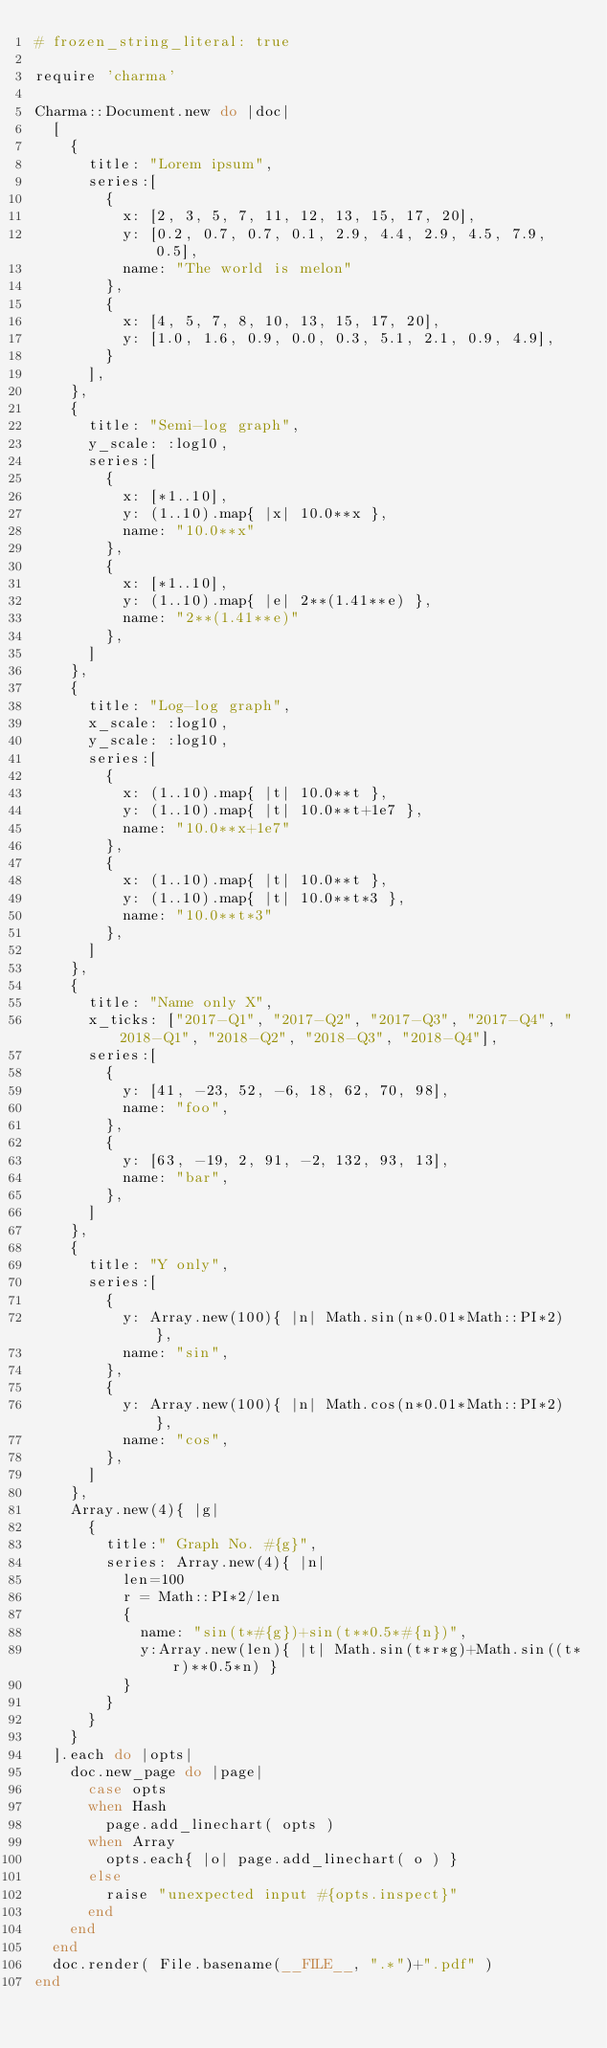<code> <loc_0><loc_0><loc_500><loc_500><_Ruby_># frozen_string_literal: true

require 'charma'

Charma::Document.new do |doc|
  [
    {
      title: "Lorem ipsum",
      series:[
        {
          x: [2, 3, 5, 7, 11, 12, 13, 15, 17, 20],
          y: [0.2, 0.7, 0.7, 0.1, 2.9, 4.4, 2.9, 4.5, 7.9, 0.5],
          name: "The world is melon"
        },
        {
          x: [4, 5, 7, 8, 10, 13, 15, 17, 20],
          y: [1.0, 1.6, 0.9, 0.0, 0.3, 5.1, 2.1, 0.9, 4.9],
        }
      ],
    },
    {
      title: "Semi-log graph",
      y_scale: :log10,
      series:[
        {
          x: [*1..10],
          y: (1..10).map{ |x| 10.0**x },
          name: "10.0**x"
        },
        {
          x: [*1..10],
          y: (1..10).map{ |e| 2**(1.41**e) },
          name: "2**(1.41**e)"
        },
      ]
    },
    {
      title: "Log-log graph",
      x_scale: :log10,
      y_scale: :log10,
      series:[
        {
          x: (1..10).map{ |t| 10.0**t },
          y: (1..10).map{ |t| 10.0**t+1e7 },
          name: "10.0**x+1e7"
        },
        {
          x: (1..10).map{ |t| 10.0**t },
          y: (1..10).map{ |t| 10.0**t*3 },
          name: "10.0**t*3"
        },
      ]
    },
    {
      title: "Name only X",
      x_ticks: ["2017-Q1", "2017-Q2", "2017-Q3", "2017-Q4", "2018-Q1", "2018-Q2", "2018-Q3", "2018-Q4"],
      series:[
        {
          y: [41, -23, 52, -6, 18, 62, 70, 98],
          name: "foo",
        },
        {
          y: [63, -19, 2, 91, -2, 132, 93, 13],
          name: "bar",
        },
      ]
    },
    {
      title: "Y only",
      series:[
        {
          y: Array.new(100){ |n| Math.sin(n*0.01*Math::PI*2) },
          name: "sin",
        },
        {
          y: Array.new(100){ |n| Math.cos(n*0.01*Math::PI*2) },
          name: "cos",
        },
      ]
    },
    Array.new(4){ |g|
      {
        title:" Graph No. #{g}",
        series: Array.new(4){ |n|
          len=100
          r = Math::PI*2/len
          {
            name: "sin(t*#{g})+sin(t**0.5*#{n})",
            y:Array.new(len){ |t| Math.sin(t*r*g)+Math.sin((t*r)**0.5*n) }
          }
        }
      }
    }
  ].each do |opts|
    doc.new_page do |page|
      case opts
      when Hash
        page.add_linechart( opts )
      when Array
        opts.each{ |o| page.add_linechart( o ) }
      else
        raise "unexpected input #{opts.inspect}"
      end
    end
  end
  doc.render( File.basename(__FILE__, ".*")+".pdf" )
end
</code> 